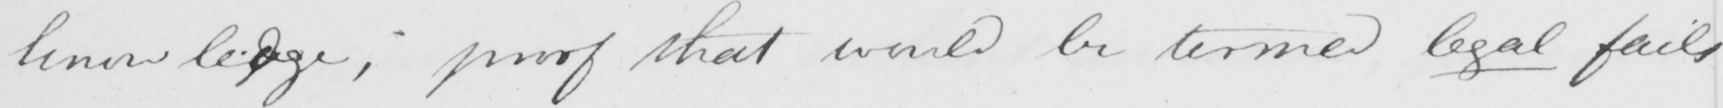Can you read and transcribe this handwriting? -knowlegdge , proof that would be termed legal fails 